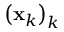Convert formula to latex. <formula><loc_0><loc_0><loc_500><loc_500>\left ( x _ { k } \right ) _ { k }</formula> 